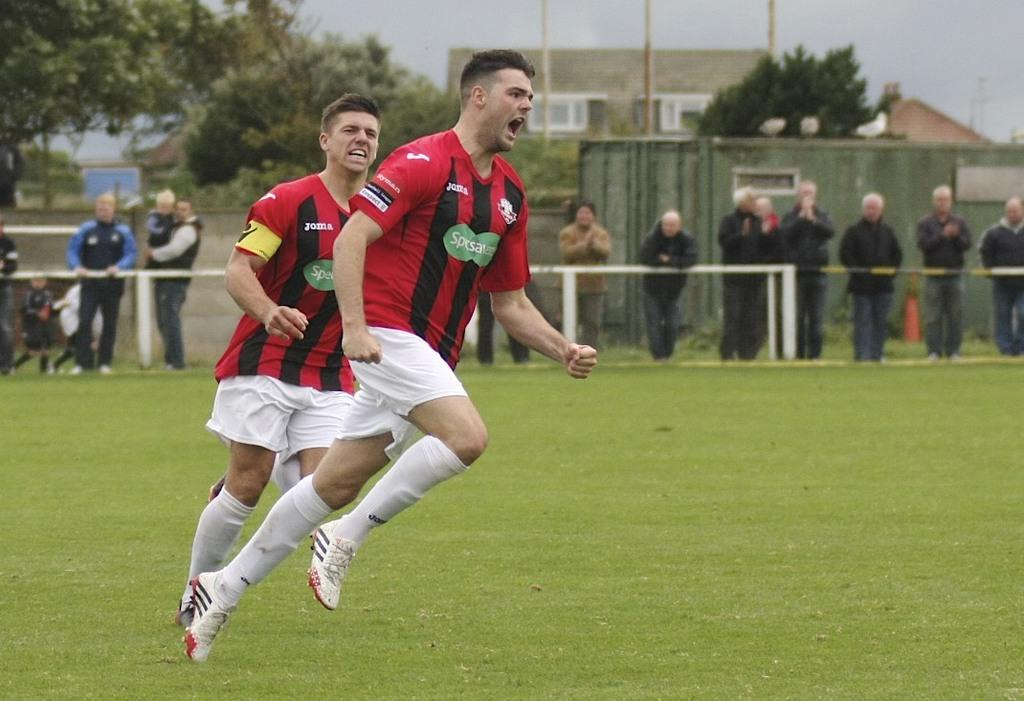What are the two men on the left side of the image doing? The two men on the left side of the image are running. What can be seen in the background of the image? There are people, trees, buildings, and the sky visible in the background of the image. Can you describe the setting of the image? The image appears to be set in an urban environment with buildings and trees in the background. What is the opinion of the volcano on the right side of the image? There is no volcano present in the image; it only features two men running and elements in the background. 